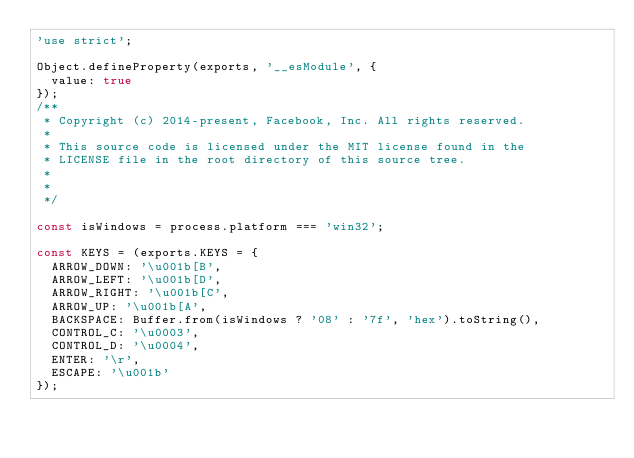Convert code to text. <code><loc_0><loc_0><loc_500><loc_500><_JavaScript_>'use strict';

Object.defineProperty(exports, '__esModule', {
  value: true
});
/**
 * Copyright (c) 2014-present, Facebook, Inc. All rights reserved.
 *
 * This source code is licensed under the MIT license found in the
 * LICENSE file in the root directory of this source tree.
 *
 *
 */

const isWindows = process.platform === 'win32';

const KEYS = (exports.KEYS = {
  ARROW_DOWN: '\u001b[B',
  ARROW_LEFT: '\u001b[D',
  ARROW_RIGHT: '\u001b[C',
  ARROW_UP: '\u001b[A',
  BACKSPACE: Buffer.from(isWindows ? '08' : '7f', 'hex').toString(),
  CONTROL_C: '\u0003',
  CONTROL_D: '\u0004',
  ENTER: '\r',
  ESCAPE: '\u001b'
});
</code> 